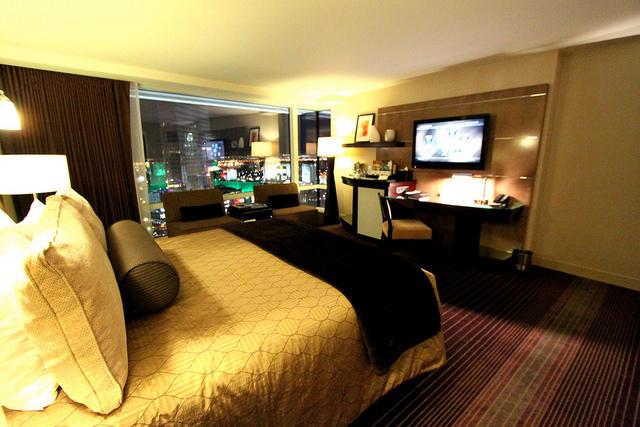Is the television on in the photo?
Write a very short answer. Yes. Does the carpet have stripes?
Short answer required. Yes. How many pillows are on the bed?
Quick response, please. 5. 